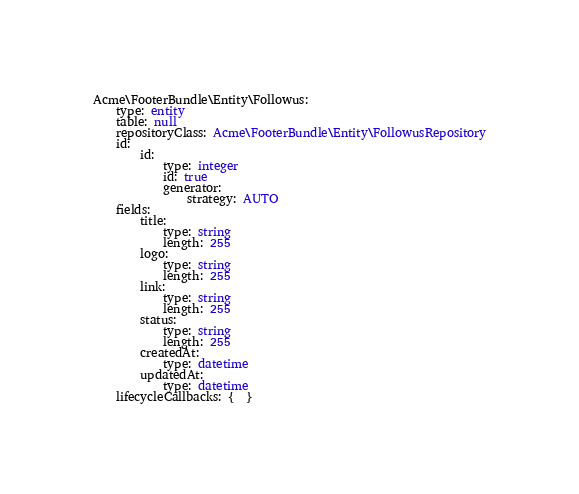Convert code to text. <code><loc_0><loc_0><loc_500><loc_500><_YAML_>Acme\FooterBundle\Entity\Followus:
    type: entity
    table: null
    repositoryClass: Acme\FooterBundle\Entity\FollowusRepository
    id:
        id:
            type: integer
            id: true
            generator:
                strategy: AUTO
    fields:
        title:
            type: string
            length: 255
        logo:
            type: string
            length: 255
        link:
            type: string
            length: 255
        status:
            type: string
            length: 255
        createdAt:
            type: datetime
        updatedAt:
            type: datetime
    lifecycleCallbacks: {  }
</code> 